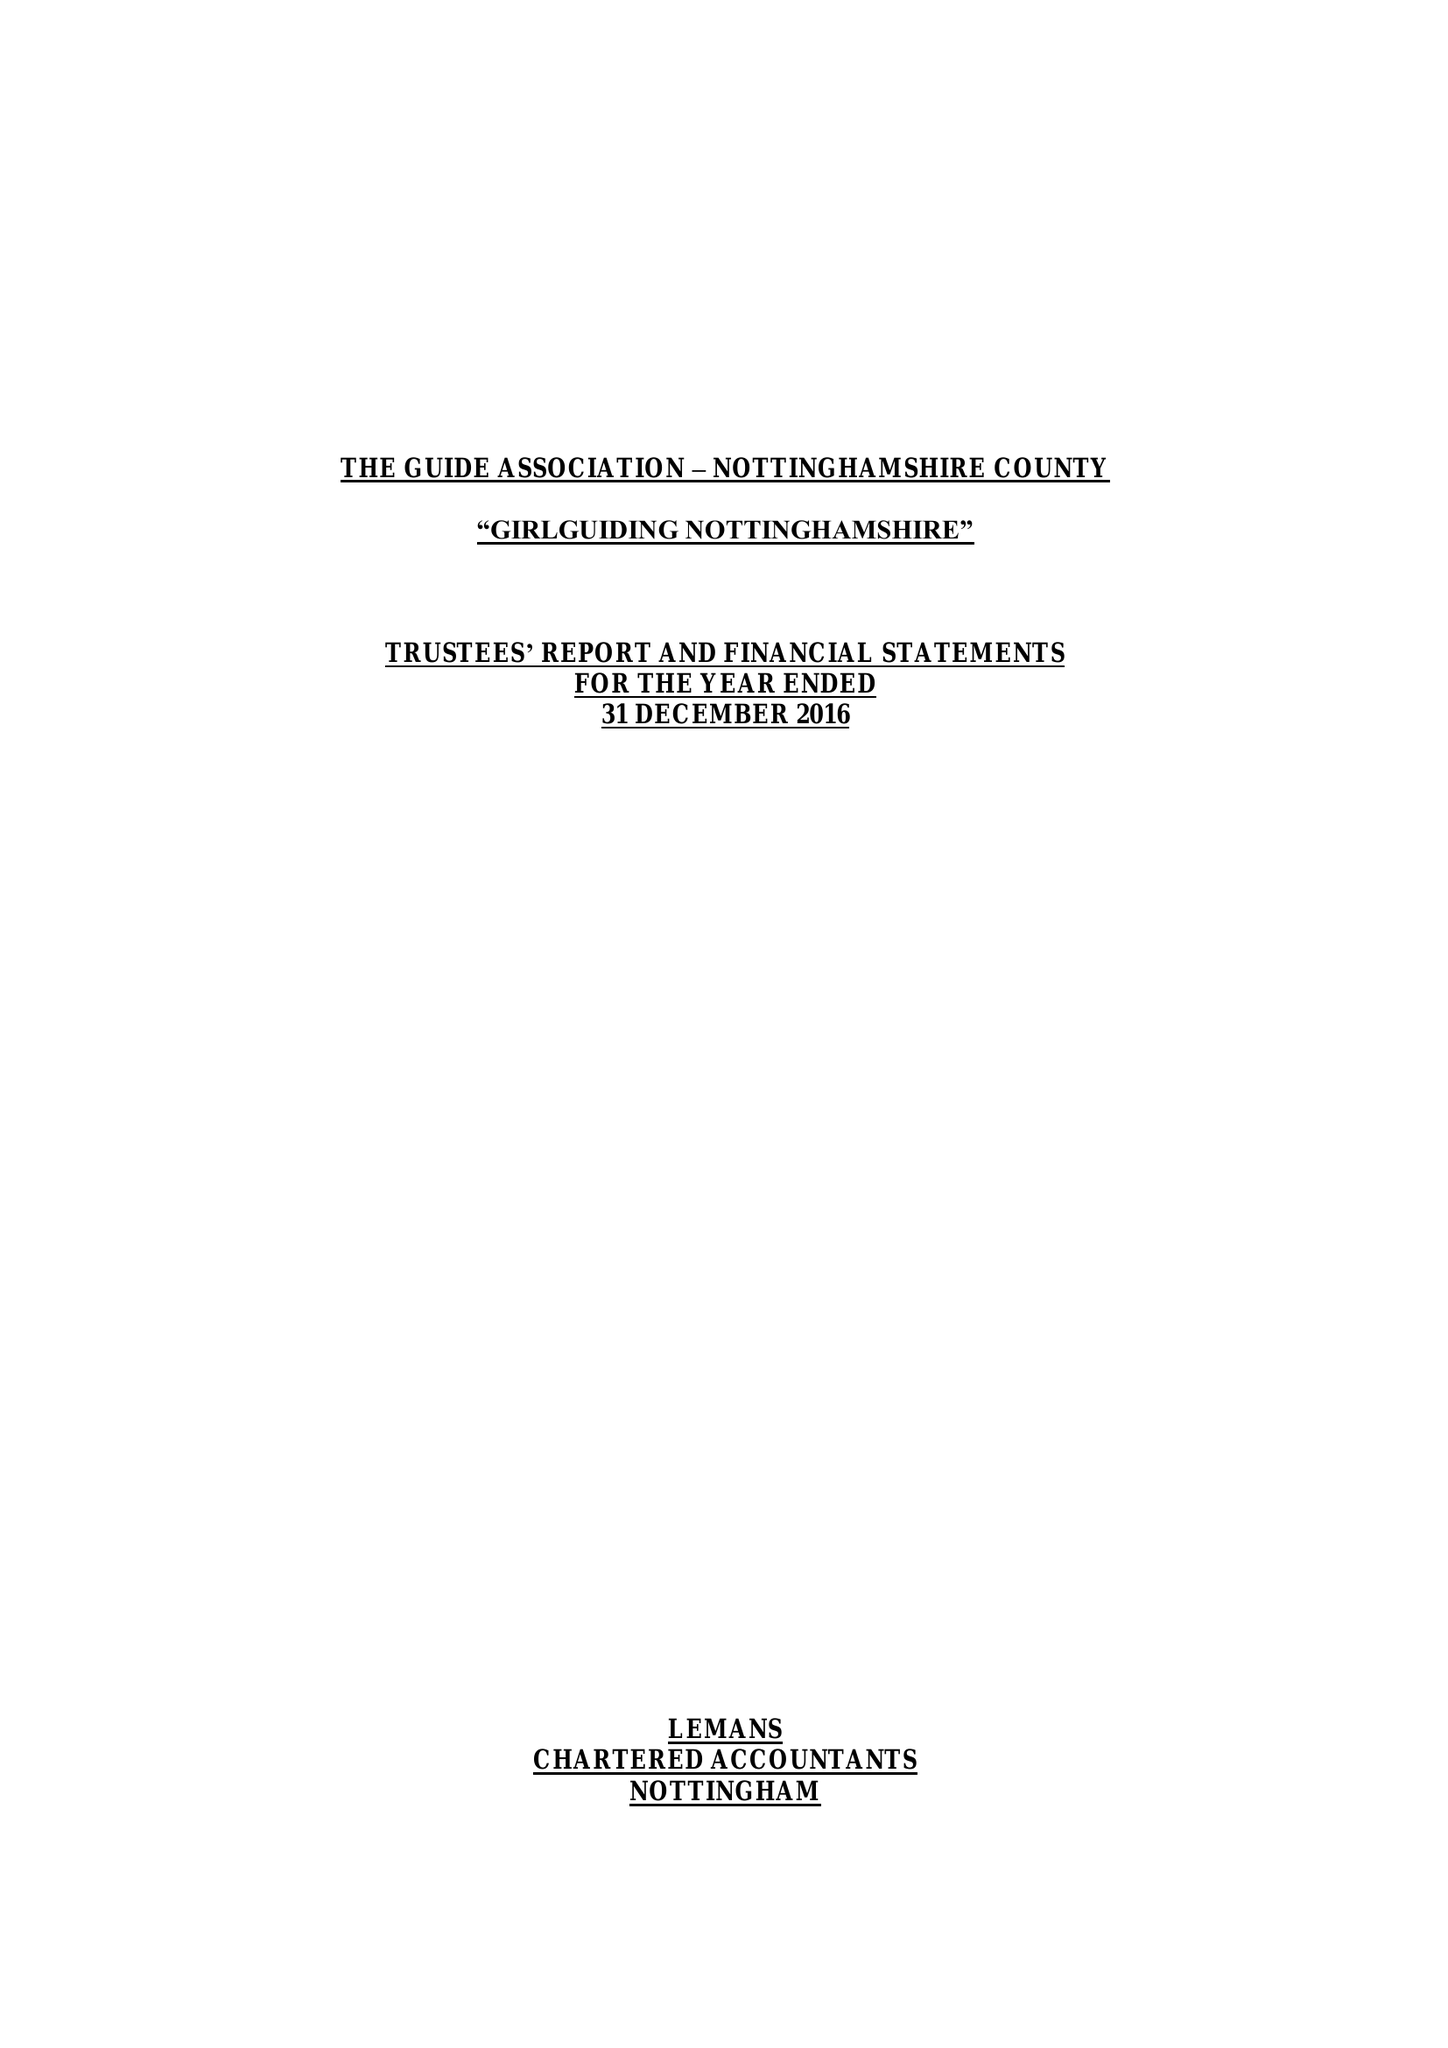What is the value for the address__street_line?
Answer the question using a single word or phrase. 16-18 BURTON ROAD 